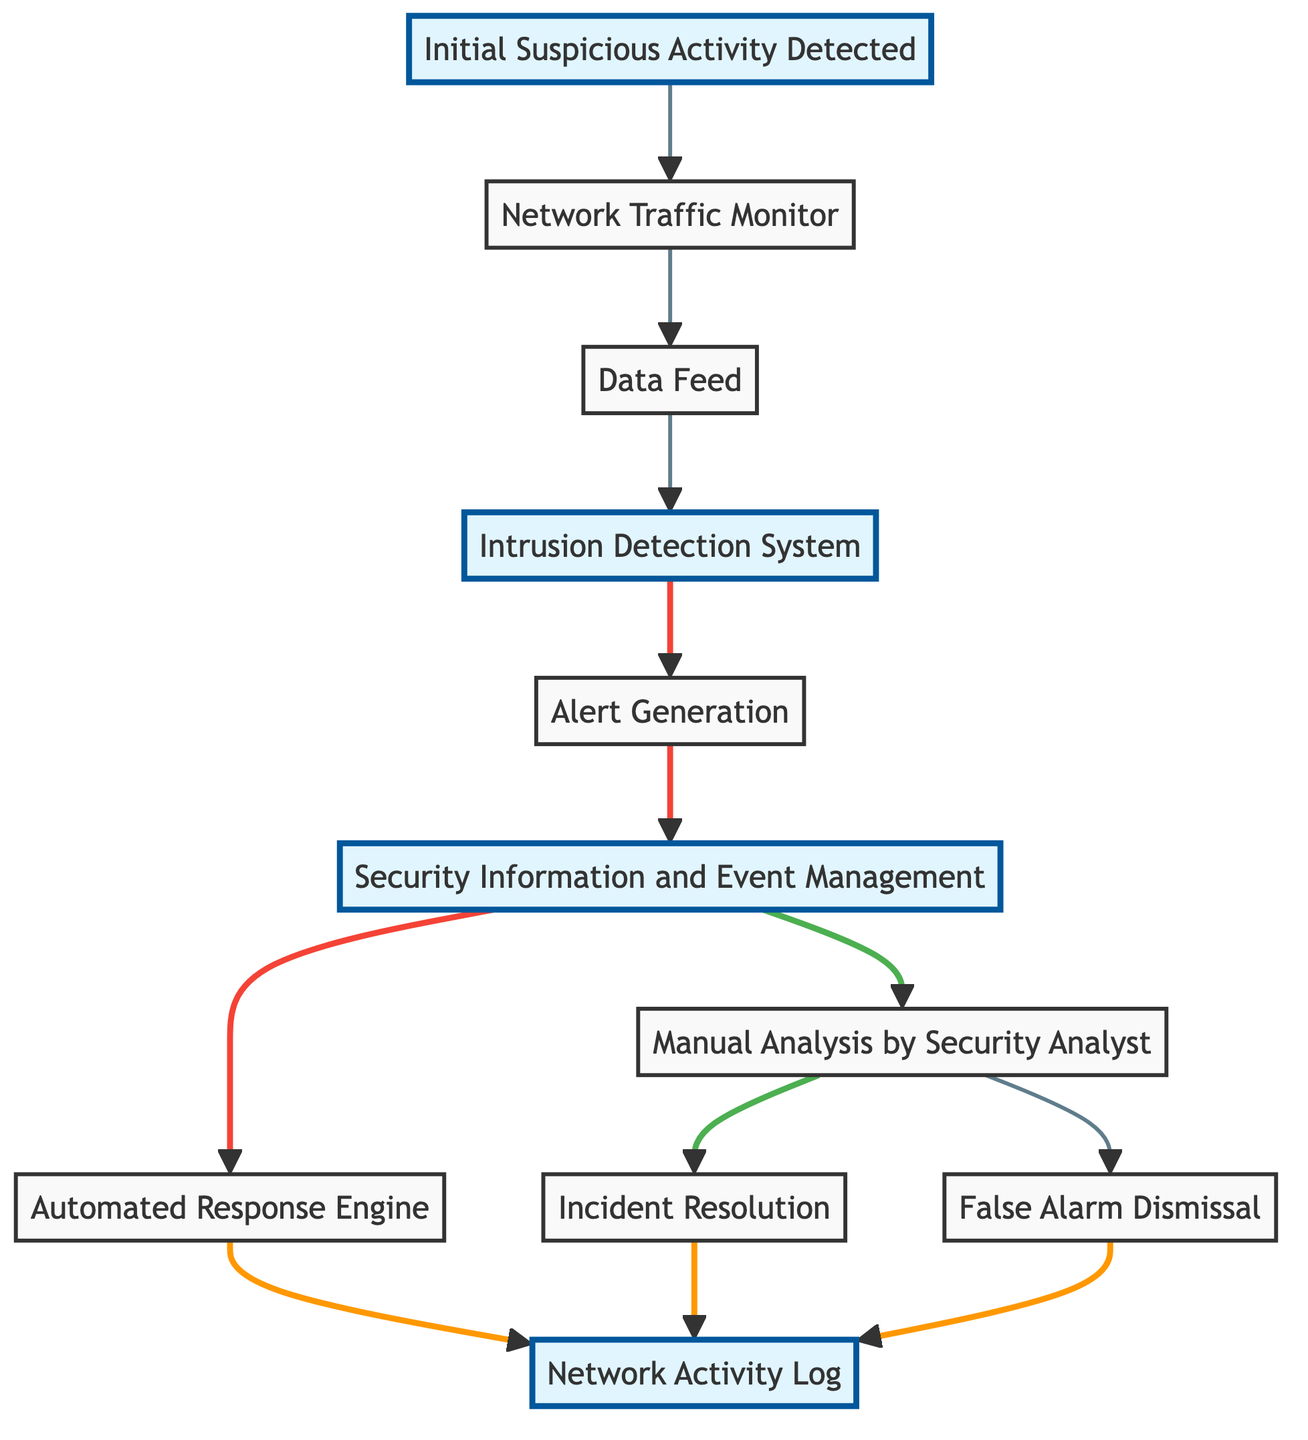What is the first step in the network intrusion detection workflow? The first node in the diagram is "Initial Suspicious Activity Detected," indicating that detection starts with the identification of suspicious activity.
Answer: Initial Suspicious Activity Detected How many nodes are in the directed graph? By counting, there are a total of 11 distinct nodes, representing different steps in the workflow.
Answer: 11 What is the last action taken after an incident resolution? The "Network Activity Log" node indicates that both "Incident Resolution" and "False Alarm Dismissal" lead to logging the activity after those processes are completed.
Answer: Network Activity Log From which node does the "Automated Response Engine" receive input? The "Automated Response Engine" receives input from the "Security Information and Event Management" node as indicated by the directed edge connecting them.
Answer: Security Information and Event Management What action follows "Manual Analysis by Security Analyst"? After "Manual Analysis by Security Analyst," the actions that follow are "Incident Resolution" and "False Alarm Dismissal," depending on the analysis result.
Answer: Incident Resolution, False Alarm Dismissal Which two nodes are highlighted in the diagram? The highlighted nodes in the diagram are "Initial Suspicious Activity Detected," "Intrusion Detection System," "Security Information and Event Management," and "Network Activity Log," indicating key focus areas in the workflow.
Answer: Initial Suspicious Activity Detected, Intrusion Detection System, Security Information and Event Management, Network Activity Log How does suspicious activity lead to alert generation? The workflow shows that once "Initial Suspicious Activity Detected" is identified, it flows through "Network Traffic Monitor" to "Data Feed," then to "Intrusion Detection System," which leads to "Alert Generation." This progression demonstrates how activity detection creates alerts.
Answer: Through the flow from initial detection to alert generation What are the two possible outcomes after manual analysis? The outcomes are either "Incident Resolution," indicating a confirmed threat and necessary actions taken, or "False Alarm Dismissal," which means the detected activity was not a threat and is discarded.
Answer: Incident Resolution, False Alarm Dismissal Which node does the "Intrusion Detection System" directly connect to? The "Intrusion Detection System" directly connects to the "Alert Generation" node, indicating that the IDS triggers alerts based on confirmed intrusions.
Answer: Alert Generation 